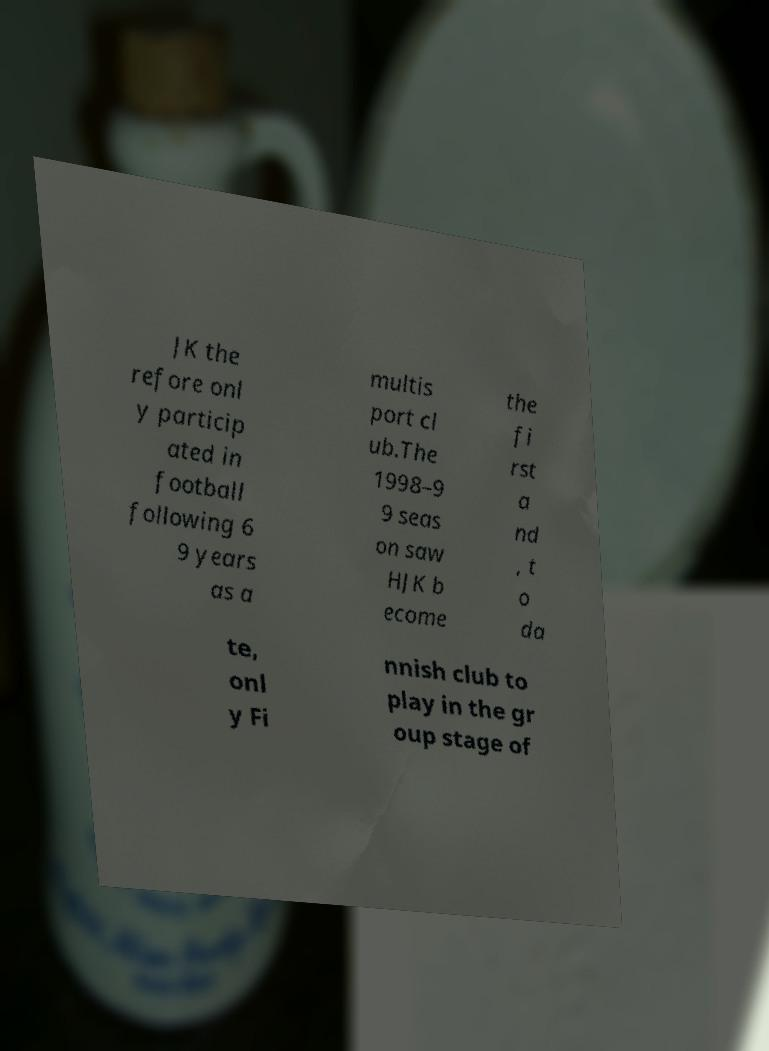Could you assist in decoding the text presented in this image and type it out clearly? JK the refore onl y particip ated in football following 6 9 years as a multis port cl ub.The 1998–9 9 seas on saw HJK b ecome the fi rst a nd , t o da te, onl y Fi nnish club to play in the gr oup stage of 